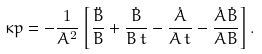<formula> <loc_0><loc_0><loc_500><loc_500>\kappa p = - \frac { 1 } { A ^ { 2 } } \left [ \frac { \ddot { B } } { B } + \frac { \dot { B } } { B \, t } - \frac { \dot { A } } { A \, t } - \frac { \dot { A } \dot { B } } { A B } \right ] .</formula> 